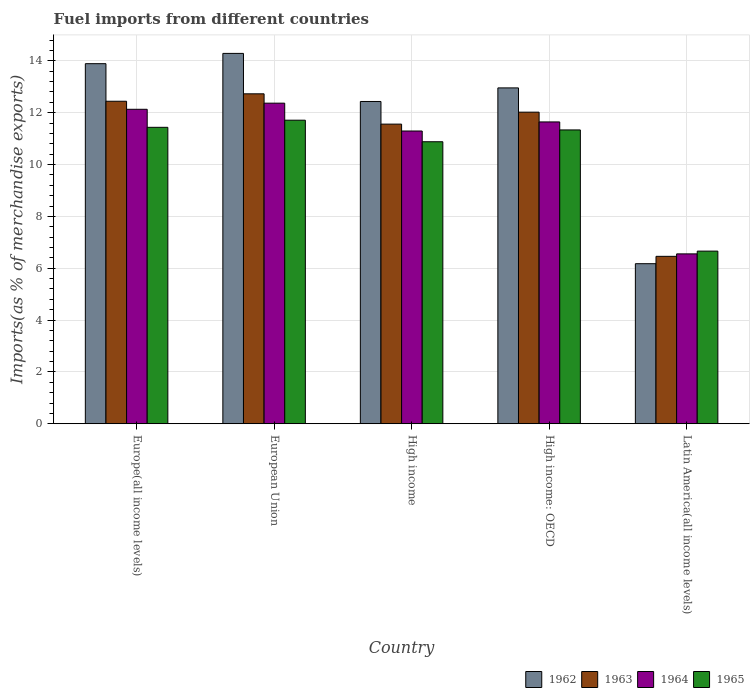Are the number of bars per tick equal to the number of legend labels?
Your answer should be compact. Yes. What is the label of the 1st group of bars from the left?
Offer a terse response. Europe(all income levels). In how many cases, is the number of bars for a given country not equal to the number of legend labels?
Keep it short and to the point. 0. What is the percentage of imports to different countries in 1965 in High income: OECD?
Ensure brevity in your answer.  11.34. Across all countries, what is the maximum percentage of imports to different countries in 1964?
Offer a terse response. 12.37. Across all countries, what is the minimum percentage of imports to different countries in 1963?
Your answer should be very brief. 6.46. In which country was the percentage of imports to different countries in 1964 maximum?
Provide a succinct answer. European Union. In which country was the percentage of imports to different countries in 1963 minimum?
Offer a terse response. Latin America(all income levels). What is the total percentage of imports to different countries in 1962 in the graph?
Your response must be concise. 59.75. What is the difference between the percentage of imports to different countries in 1964 in High income and that in Latin America(all income levels)?
Keep it short and to the point. 4.74. What is the difference between the percentage of imports to different countries in 1963 in High income and the percentage of imports to different countries in 1964 in Latin America(all income levels)?
Your answer should be compact. 5.01. What is the average percentage of imports to different countries in 1963 per country?
Give a very brief answer. 11.04. What is the difference between the percentage of imports to different countries of/in 1964 and percentage of imports to different countries of/in 1963 in Europe(all income levels)?
Offer a terse response. -0.31. What is the ratio of the percentage of imports to different countries in 1965 in Europe(all income levels) to that in High income: OECD?
Make the answer very short. 1.01. What is the difference between the highest and the second highest percentage of imports to different countries in 1963?
Provide a succinct answer. -0.71. What is the difference between the highest and the lowest percentage of imports to different countries in 1965?
Give a very brief answer. 5.05. In how many countries, is the percentage of imports to different countries in 1964 greater than the average percentage of imports to different countries in 1964 taken over all countries?
Your answer should be compact. 4. Is it the case that in every country, the sum of the percentage of imports to different countries in 1963 and percentage of imports to different countries in 1965 is greater than the sum of percentage of imports to different countries in 1964 and percentage of imports to different countries in 1962?
Provide a succinct answer. No. What does the 4th bar from the left in High income represents?
Provide a succinct answer. 1965. Is it the case that in every country, the sum of the percentage of imports to different countries in 1963 and percentage of imports to different countries in 1965 is greater than the percentage of imports to different countries in 1964?
Provide a short and direct response. Yes. Are all the bars in the graph horizontal?
Provide a succinct answer. No. How many countries are there in the graph?
Provide a short and direct response. 5. Are the values on the major ticks of Y-axis written in scientific E-notation?
Make the answer very short. No. Where does the legend appear in the graph?
Provide a short and direct response. Bottom right. How are the legend labels stacked?
Your response must be concise. Horizontal. What is the title of the graph?
Your answer should be very brief. Fuel imports from different countries. Does "1988" appear as one of the legend labels in the graph?
Ensure brevity in your answer.  No. What is the label or title of the X-axis?
Give a very brief answer. Country. What is the label or title of the Y-axis?
Provide a succinct answer. Imports(as % of merchandise exports). What is the Imports(as % of merchandise exports) in 1962 in Europe(all income levels)?
Give a very brief answer. 13.89. What is the Imports(as % of merchandise exports) in 1963 in Europe(all income levels)?
Provide a short and direct response. 12.44. What is the Imports(as % of merchandise exports) in 1964 in Europe(all income levels)?
Provide a succinct answer. 12.13. What is the Imports(as % of merchandise exports) of 1965 in Europe(all income levels)?
Provide a succinct answer. 11.44. What is the Imports(as % of merchandise exports) in 1962 in European Union?
Offer a very short reply. 14.29. What is the Imports(as % of merchandise exports) of 1963 in European Union?
Your answer should be compact. 12.73. What is the Imports(as % of merchandise exports) of 1964 in European Union?
Give a very brief answer. 12.37. What is the Imports(as % of merchandise exports) of 1965 in European Union?
Offer a very short reply. 11.71. What is the Imports(as % of merchandise exports) in 1962 in High income?
Your answer should be very brief. 12.43. What is the Imports(as % of merchandise exports) in 1963 in High income?
Offer a terse response. 11.56. What is the Imports(as % of merchandise exports) of 1964 in High income?
Give a very brief answer. 11.29. What is the Imports(as % of merchandise exports) in 1965 in High income?
Your answer should be compact. 10.88. What is the Imports(as % of merchandise exports) in 1962 in High income: OECD?
Give a very brief answer. 12.96. What is the Imports(as % of merchandise exports) in 1963 in High income: OECD?
Give a very brief answer. 12.02. What is the Imports(as % of merchandise exports) in 1964 in High income: OECD?
Your response must be concise. 11.64. What is the Imports(as % of merchandise exports) of 1965 in High income: OECD?
Ensure brevity in your answer.  11.34. What is the Imports(as % of merchandise exports) of 1962 in Latin America(all income levels)?
Keep it short and to the point. 6.17. What is the Imports(as % of merchandise exports) of 1963 in Latin America(all income levels)?
Your answer should be compact. 6.46. What is the Imports(as % of merchandise exports) in 1964 in Latin America(all income levels)?
Give a very brief answer. 6.55. What is the Imports(as % of merchandise exports) in 1965 in Latin America(all income levels)?
Your answer should be very brief. 6.66. Across all countries, what is the maximum Imports(as % of merchandise exports) in 1962?
Your answer should be compact. 14.29. Across all countries, what is the maximum Imports(as % of merchandise exports) in 1963?
Your answer should be very brief. 12.73. Across all countries, what is the maximum Imports(as % of merchandise exports) in 1964?
Provide a short and direct response. 12.37. Across all countries, what is the maximum Imports(as % of merchandise exports) of 1965?
Give a very brief answer. 11.71. Across all countries, what is the minimum Imports(as % of merchandise exports) of 1962?
Give a very brief answer. 6.17. Across all countries, what is the minimum Imports(as % of merchandise exports) in 1963?
Your answer should be very brief. 6.46. Across all countries, what is the minimum Imports(as % of merchandise exports) in 1964?
Provide a short and direct response. 6.55. Across all countries, what is the minimum Imports(as % of merchandise exports) in 1965?
Your answer should be compact. 6.66. What is the total Imports(as % of merchandise exports) of 1962 in the graph?
Your response must be concise. 59.75. What is the total Imports(as % of merchandise exports) in 1963 in the graph?
Offer a very short reply. 55.21. What is the total Imports(as % of merchandise exports) of 1964 in the graph?
Provide a succinct answer. 53.99. What is the total Imports(as % of merchandise exports) of 1965 in the graph?
Provide a succinct answer. 52.02. What is the difference between the Imports(as % of merchandise exports) in 1962 in Europe(all income levels) and that in European Union?
Give a very brief answer. -0.4. What is the difference between the Imports(as % of merchandise exports) of 1963 in Europe(all income levels) and that in European Union?
Give a very brief answer. -0.29. What is the difference between the Imports(as % of merchandise exports) in 1964 in Europe(all income levels) and that in European Union?
Offer a very short reply. -0.24. What is the difference between the Imports(as % of merchandise exports) of 1965 in Europe(all income levels) and that in European Union?
Your response must be concise. -0.27. What is the difference between the Imports(as % of merchandise exports) in 1962 in Europe(all income levels) and that in High income?
Offer a very short reply. 1.46. What is the difference between the Imports(as % of merchandise exports) in 1963 in Europe(all income levels) and that in High income?
Your response must be concise. 0.88. What is the difference between the Imports(as % of merchandise exports) in 1964 in Europe(all income levels) and that in High income?
Offer a terse response. 0.84. What is the difference between the Imports(as % of merchandise exports) in 1965 in Europe(all income levels) and that in High income?
Offer a terse response. 0.56. What is the difference between the Imports(as % of merchandise exports) in 1962 in Europe(all income levels) and that in High income: OECD?
Make the answer very short. 0.93. What is the difference between the Imports(as % of merchandise exports) in 1963 in Europe(all income levels) and that in High income: OECD?
Offer a terse response. 0.42. What is the difference between the Imports(as % of merchandise exports) in 1964 in Europe(all income levels) and that in High income: OECD?
Your answer should be very brief. 0.49. What is the difference between the Imports(as % of merchandise exports) of 1965 in Europe(all income levels) and that in High income: OECD?
Provide a short and direct response. 0.1. What is the difference between the Imports(as % of merchandise exports) of 1962 in Europe(all income levels) and that in Latin America(all income levels)?
Ensure brevity in your answer.  7.72. What is the difference between the Imports(as % of merchandise exports) in 1963 in Europe(all income levels) and that in Latin America(all income levels)?
Offer a very short reply. 5.98. What is the difference between the Imports(as % of merchandise exports) in 1964 in Europe(all income levels) and that in Latin America(all income levels)?
Ensure brevity in your answer.  5.58. What is the difference between the Imports(as % of merchandise exports) in 1965 in Europe(all income levels) and that in Latin America(all income levels)?
Keep it short and to the point. 4.78. What is the difference between the Imports(as % of merchandise exports) of 1962 in European Union and that in High income?
Offer a terse response. 1.86. What is the difference between the Imports(as % of merchandise exports) in 1963 in European Union and that in High income?
Keep it short and to the point. 1.17. What is the difference between the Imports(as % of merchandise exports) in 1964 in European Union and that in High income?
Make the answer very short. 1.07. What is the difference between the Imports(as % of merchandise exports) in 1965 in European Union and that in High income?
Your answer should be compact. 0.83. What is the difference between the Imports(as % of merchandise exports) in 1962 in European Union and that in High income: OECD?
Provide a short and direct response. 1.33. What is the difference between the Imports(as % of merchandise exports) of 1963 in European Union and that in High income: OECD?
Make the answer very short. 0.71. What is the difference between the Imports(as % of merchandise exports) in 1964 in European Union and that in High income: OECD?
Your answer should be compact. 0.72. What is the difference between the Imports(as % of merchandise exports) of 1965 in European Union and that in High income: OECD?
Offer a terse response. 0.38. What is the difference between the Imports(as % of merchandise exports) in 1962 in European Union and that in Latin America(all income levels)?
Your answer should be compact. 8.11. What is the difference between the Imports(as % of merchandise exports) of 1963 in European Union and that in Latin America(all income levels)?
Your response must be concise. 6.27. What is the difference between the Imports(as % of merchandise exports) of 1964 in European Union and that in Latin America(all income levels)?
Keep it short and to the point. 5.82. What is the difference between the Imports(as % of merchandise exports) in 1965 in European Union and that in Latin America(all income levels)?
Provide a succinct answer. 5.05. What is the difference between the Imports(as % of merchandise exports) in 1962 in High income and that in High income: OECD?
Make the answer very short. -0.52. What is the difference between the Imports(as % of merchandise exports) of 1963 in High income and that in High income: OECD?
Offer a terse response. -0.46. What is the difference between the Imports(as % of merchandise exports) of 1964 in High income and that in High income: OECD?
Keep it short and to the point. -0.35. What is the difference between the Imports(as % of merchandise exports) in 1965 in High income and that in High income: OECD?
Provide a succinct answer. -0.46. What is the difference between the Imports(as % of merchandise exports) of 1962 in High income and that in Latin America(all income levels)?
Your answer should be compact. 6.26. What is the difference between the Imports(as % of merchandise exports) of 1963 in High income and that in Latin America(all income levels)?
Ensure brevity in your answer.  5.1. What is the difference between the Imports(as % of merchandise exports) in 1964 in High income and that in Latin America(all income levels)?
Provide a short and direct response. 4.74. What is the difference between the Imports(as % of merchandise exports) of 1965 in High income and that in Latin America(all income levels)?
Keep it short and to the point. 4.22. What is the difference between the Imports(as % of merchandise exports) of 1962 in High income: OECD and that in Latin America(all income levels)?
Provide a short and direct response. 6.78. What is the difference between the Imports(as % of merchandise exports) of 1963 in High income: OECD and that in Latin America(all income levels)?
Your answer should be very brief. 5.56. What is the difference between the Imports(as % of merchandise exports) in 1964 in High income: OECD and that in Latin America(all income levels)?
Provide a succinct answer. 5.09. What is the difference between the Imports(as % of merchandise exports) of 1965 in High income: OECD and that in Latin America(all income levels)?
Provide a short and direct response. 4.68. What is the difference between the Imports(as % of merchandise exports) in 1962 in Europe(all income levels) and the Imports(as % of merchandise exports) in 1963 in European Union?
Provide a short and direct response. 1.16. What is the difference between the Imports(as % of merchandise exports) of 1962 in Europe(all income levels) and the Imports(as % of merchandise exports) of 1964 in European Union?
Offer a very short reply. 1.52. What is the difference between the Imports(as % of merchandise exports) in 1962 in Europe(all income levels) and the Imports(as % of merchandise exports) in 1965 in European Union?
Give a very brief answer. 2.18. What is the difference between the Imports(as % of merchandise exports) of 1963 in Europe(all income levels) and the Imports(as % of merchandise exports) of 1964 in European Union?
Provide a succinct answer. 0.07. What is the difference between the Imports(as % of merchandise exports) of 1963 in Europe(all income levels) and the Imports(as % of merchandise exports) of 1965 in European Union?
Ensure brevity in your answer.  0.73. What is the difference between the Imports(as % of merchandise exports) of 1964 in Europe(all income levels) and the Imports(as % of merchandise exports) of 1965 in European Union?
Provide a succinct answer. 0.42. What is the difference between the Imports(as % of merchandise exports) in 1962 in Europe(all income levels) and the Imports(as % of merchandise exports) in 1963 in High income?
Offer a very short reply. 2.33. What is the difference between the Imports(as % of merchandise exports) in 1962 in Europe(all income levels) and the Imports(as % of merchandise exports) in 1964 in High income?
Your response must be concise. 2.6. What is the difference between the Imports(as % of merchandise exports) in 1962 in Europe(all income levels) and the Imports(as % of merchandise exports) in 1965 in High income?
Make the answer very short. 3.01. What is the difference between the Imports(as % of merchandise exports) in 1963 in Europe(all income levels) and the Imports(as % of merchandise exports) in 1964 in High income?
Give a very brief answer. 1.15. What is the difference between the Imports(as % of merchandise exports) of 1963 in Europe(all income levels) and the Imports(as % of merchandise exports) of 1965 in High income?
Your answer should be compact. 1.56. What is the difference between the Imports(as % of merchandise exports) of 1964 in Europe(all income levels) and the Imports(as % of merchandise exports) of 1965 in High income?
Your answer should be compact. 1.25. What is the difference between the Imports(as % of merchandise exports) of 1962 in Europe(all income levels) and the Imports(as % of merchandise exports) of 1963 in High income: OECD?
Offer a very short reply. 1.87. What is the difference between the Imports(as % of merchandise exports) in 1962 in Europe(all income levels) and the Imports(as % of merchandise exports) in 1964 in High income: OECD?
Your answer should be compact. 2.25. What is the difference between the Imports(as % of merchandise exports) of 1962 in Europe(all income levels) and the Imports(as % of merchandise exports) of 1965 in High income: OECD?
Ensure brevity in your answer.  2.56. What is the difference between the Imports(as % of merchandise exports) of 1963 in Europe(all income levels) and the Imports(as % of merchandise exports) of 1964 in High income: OECD?
Ensure brevity in your answer.  0.8. What is the difference between the Imports(as % of merchandise exports) in 1963 in Europe(all income levels) and the Imports(as % of merchandise exports) in 1965 in High income: OECD?
Keep it short and to the point. 1.11. What is the difference between the Imports(as % of merchandise exports) of 1964 in Europe(all income levels) and the Imports(as % of merchandise exports) of 1965 in High income: OECD?
Ensure brevity in your answer.  0.8. What is the difference between the Imports(as % of merchandise exports) in 1962 in Europe(all income levels) and the Imports(as % of merchandise exports) in 1963 in Latin America(all income levels)?
Keep it short and to the point. 7.43. What is the difference between the Imports(as % of merchandise exports) of 1962 in Europe(all income levels) and the Imports(as % of merchandise exports) of 1964 in Latin America(all income levels)?
Offer a very short reply. 7.34. What is the difference between the Imports(as % of merchandise exports) in 1962 in Europe(all income levels) and the Imports(as % of merchandise exports) in 1965 in Latin America(all income levels)?
Offer a very short reply. 7.23. What is the difference between the Imports(as % of merchandise exports) of 1963 in Europe(all income levels) and the Imports(as % of merchandise exports) of 1964 in Latin America(all income levels)?
Your response must be concise. 5.89. What is the difference between the Imports(as % of merchandise exports) of 1963 in Europe(all income levels) and the Imports(as % of merchandise exports) of 1965 in Latin America(all income levels)?
Make the answer very short. 5.78. What is the difference between the Imports(as % of merchandise exports) in 1964 in Europe(all income levels) and the Imports(as % of merchandise exports) in 1965 in Latin America(all income levels)?
Provide a short and direct response. 5.47. What is the difference between the Imports(as % of merchandise exports) in 1962 in European Union and the Imports(as % of merchandise exports) in 1963 in High income?
Keep it short and to the point. 2.73. What is the difference between the Imports(as % of merchandise exports) in 1962 in European Union and the Imports(as % of merchandise exports) in 1964 in High income?
Provide a succinct answer. 2.99. What is the difference between the Imports(as % of merchandise exports) in 1962 in European Union and the Imports(as % of merchandise exports) in 1965 in High income?
Your response must be concise. 3.41. What is the difference between the Imports(as % of merchandise exports) of 1963 in European Union and the Imports(as % of merchandise exports) of 1964 in High income?
Your response must be concise. 1.43. What is the difference between the Imports(as % of merchandise exports) in 1963 in European Union and the Imports(as % of merchandise exports) in 1965 in High income?
Give a very brief answer. 1.85. What is the difference between the Imports(as % of merchandise exports) in 1964 in European Union and the Imports(as % of merchandise exports) in 1965 in High income?
Provide a short and direct response. 1.49. What is the difference between the Imports(as % of merchandise exports) in 1962 in European Union and the Imports(as % of merchandise exports) in 1963 in High income: OECD?
Your answer should be compact. 2.27. What is the difference between the Imports(as % of merchandise exports) of 1962 in European Union and the Imports(as % of merchandise exports) of 1964 in High income: OECD?
Your answer should be very brief. 2.64. What is the difference between the Imports(as % of merchandise exports) in 1962 in European Union and the Imports(as % of merchandise exports) in 1965 in High income: OECD?
Keep it short and to the point. 2.95. What is the difference between the Imports(as % of merchandise exports) of 1963 in European Union and the Imports(as % of merchandise exports) of 1964 in High income: OECD?
Offer a terse response. 1.08. What is the difference between the Imports(as % of merchandise exports) of 1963 in European Union and the Imports(as % of merchandise exports) of 1965 in High income: OECD?
Offer a terse response. 1.39. What is the difference between the Imports(as % of merchandise exports) of 1964 in European Union and the Imports(as % of merchandise exports) of 1965 in High income: OECD?
Your answer should be very brief. 1.03. What is the difference between the Imports(as % of merchandise exports) of 1962 in European Union and the Imports(as % of merchandise exports) of 1963 in Latin America(all income levels)?
Your response must be concise. 7.83. What is the difference between the Imports(as % of merchandise exports) of 1962 in European Union and the Imports(as % of merchandise exports) of 1964 in Latin America(all income levels)?
Make the answer very short. 7.74. What is the difference between the Imports(as % of merchandise exports) in 1962 in European Union and the Imports(as % of merchandise exports) in 1965 in Latin America(all income levels)?
Make the answer very short. 7.63. What is the difference between the Imports(as % of merchandise exports) in 1963 in European Union and the Imports(as % of merchandise exports) in 1964 in Latin America(all income levels)?
Offer a very short reply. 6.18. What is the difference between the Imports(as % of merchandise exports) of 1963 in European Union and the Imports(as % of merchandise exports) of 1965 in Latin America(all income levels)?
Give a very brief answer. 6.07. What is the difference between the Imports(as % of merchandise exports) of 1964 in European Union and the Imports(as % of merchandise exports) of 1965 in Latin America(all income levels)?
Provide a succinct answer. 5.71. What is the difference between the Imports(as % of merchandise exports) of 1962 in High income and the Imports(as % of merchandise exports) of 1963 in High income: OECD?
Offer a very short reply. 0.41. What is the difference between the Imports(as % of merchandise exports) of 1962 in High income and the Imports(as % of merchandise exports) of 1964 in High income: OECD?
Offer a very short reply. 0.79. What is the difference between the Imports(as % of merchandise exports) of 1962 in High income and the Imports(as % of merchandise exports) of 1965 in High income: OECD?
Your answer should be compact. 1.1. What is the difference between the Imports(as % of merchandise exports) of 1963 in High income and the Imports(as % of merchandise exports) of 1964 in High income: OECD?
Provide a short and direct response. -0.09. What is the difference between the Imports(as % of merchandise exports) of 1963 in High income and the Imports(as % of merchandise exports) of 1965 in High income: OECD?
Provide a succinct answer. 0.22. What is the difference between the Imports(as % of merchandise exports) in 1964 in High income and the Imports(as % of merchandise exports) in 1965 in High income: OECD?
Offer a very short reply. -0.04. What is the difference between the Imports(as % of merchandise exports) of 1962 in High income and the Imports(as % of merchandise exports) of 1963 in Latin America(all income levels)?
Your response must be concise. 5.97. What is the difference between the Imports(as % of merchandise exports) of 1962 in High income and the Imports(as % of merchandise exports) of 1964 in Latin America(all income levels)?
Provide a short and direct response. 5.88. What is the difference between the Imports(as % of merchandise exports) of 1962 in High income and the Imports(as % of merchandise exports) of 1965 in Latin America(all income levels)?
Offer a very short reply. 5.77. What is the difference between the Imports(as % of merchandise exports) in 1963 in High income and the Imports(as % of merchandise exports) in 1964 in Latin America(all income levels)?
Your answer should be compact. 5.01. What is the difference between the Imports(as % of merchandise exports) of 1963 in High income and the Imports(as % of merchandise exports) of 1965 in Latin America(all income levels)?
Offer a terse response. 4.9. What is the difference between the Imports(as % of merchandise exports) of 1964 in High income and the Imports(as % of merchandise exports) of 1965 in Latin America(all income levels)?
Provide a short and direct response. 4.63. What is the difference between the Imports(as % of merchandise exports) of 1962 in High income: OECD and the Imports(as % of merchandise exports) of 1963 in Latin America(all income levels)?
Ensure brevity in your answer.  6.5. What is the difference between the Imports(as % of merchandise exports) in 1962 in High income: OECD and the Imports(as % of merchandise exports) in 1964 in Latin America(all income levels)?
Provide a short and direct response. 6.4. What is the difference between the Imports(as % of merchandise exports) of 1962 in High income: OECD and the Imports(as % of merchandise exports) of 1965 in Latin America(all income levels)?
Keep it short and to the point. 6.3. What is the difference between the Imports(as % of merchandise exports) of 1963 in High income: OECD and the Imports(as % of merchandise exports) of 1964 in Latin America(all income levels)?
Offer a very short reply. 5.47. What is the difference between the Imports(as % of merchandise exports) of 1963 in High income: OECD and the Imports(as % of merchandise exports) of 1965 in Latin America(all income levels)?
Your answer should be compact. 5.36. What is the difference between the Imports(as % of merchandise exports) in 1964 in High income: OECD and the Imports(as % of merchandise exports) in 1965 in Latin America(all income levels)?
Provide a short and direct response. 4.98. What is the average Imports(as % of merchandise exports) in 1962 per country?
Your answer should be compact. 11.95. What is the average Imports(as % of merchandise exports) of 1963 per country?
Provide a short and direct response. 11.04. What is the average Imports(as % of merchandise exports) in 1964 per country?
Make the answer very short. 10.8. What is the average Imports(as % of merchandise exports) of 1965 per country?
Give a very brief answer. 10.4. What is the difference between the Imports(as % of merchandise exports) in 1962 and Imports(as % of merchandise exports) in 1963 in Europe(all income levels)?
Ensure brevity in your answer.  1.45. What is the difference between the Imports(as % of merchandise exports) in 1962 and Imports(as % of merchandise exports) in 1964 in Europe(all income levels)?
Make the answer very short. 1.76. What is the difference between the Imports(as % of merchandise exports) in 1962 and Imports(as % of merchandise exports) in 1965 in Europe(all income levels)?
Your answer should be compact. 2.46. What is the difference between the Imports(as % of merchandise exports) of 1963 and Imports(as % of merchandise exports) of 1964 in Europe(all income levels)?
Your answer should be compact. 0.31. What is the difference between the Imports(as % of merchandise exports) of 1963 and Imports(as % of merchandise exports) of 1965 in Europe(all income levels)?
Offer a very short reply. 1.01. What is the difference between the Imports(as % of merchandise exports) in 1964 and Imports(as % of merchandise exports) in 1965 in Europe(all income levels)?
Your response must be concise. 0.7. What is the difference between the Imports(as % of merchandise exports) of 1962 and Imports(as % of merchandise exports) of 1963 in European Union?
Your answer should be very brief. 1.56. What is the difference between the Imports(as % of merchandise exports) of 1962 and Imports(as % of merchandise exports) of 1964 in European Union?
Give a very brief answer. 1.92. What is the difference between the Imports(as % of merchandise exports) in 1962 and Imports(as % of merchandise exports) in 1965 in European Union?
Ensure brevity in your answer.  2.58. What is the difference between the Imports(as % of merchandise exports) in 1963 and Imports(as % of merchandise exports) in 1964 in European Union?
Ensure brevity in your answer.  0.36. What is the difference between the Imports(as % of merchandise exports) of 1963 and Imports(as % of merchandise exports) of 1965 in European Union?
Give a very brief answer. 1.02. What is the difference between the Imports(as % of merchandise exports) in 1964 and Imports(as % of merchandise exports) in 1965 in European Union?
Your answer should be very brief. 0.66. What is the difference between the Imports(as % of merchandise exports) of 1962 and Imports(as % of merchandise exports) of 1963 in High income?
Give a very brief answer. 0.87. What is the difference between the Imports(as % of merchandise exports) of 1962 and Imports(as % of merchandise exports) of 1964 in High income?
Offer a terse response. 1.14. What is the difference between the Imports(as % of merchandise exports) of 1962 and Imports(as % of merchandise exports) of 1965 in High income?
Provide a short and direct response. 1.55. What is the difference between the Imports(as % of merchandise exports) in 1963 and Imports(as % of merchandise exports) in 1964 in High income?
Give a very brief answer. 0.27. What is the difference between the Imports(as % of merchandise exports) in 1963 and Imports(as % of merchandise exports) in 1965 in High income?
Keep it short and to the point. 0.68. What is the difference between the Imports(as % of merchandise exports) of 1964 and Imports(as % of merchandise exports) of 1965 in High income?
Provide a succinct answer. 0.41. What is the difference between the Imports(as % of merchandise exports) in 1962 and Imports(as % of merchandise exports) in 1963 in High income: OECD?
Provide a short and direct response. 0.94. What is the difference between the Imports(as % of merchandise exports) of 1962 and Imports(as % of merchandise exports) of 1964 in High income: OECD?
Keep it short and to the point. 1.31. What is the difference between the Imports(as % of merchandise exports) of 1962 and Imports(as % of merchandise exports) of 1965 in High income: OECD?
Provide a succinct answer. 1.62. What is the difference between the Imports(as % of merchandise exports) of 1963 and Imports(as % of merchandise exports) of 1964 in High income: OECD?
Keep it short and to the point. 0.38. What is the difference between the Imports(as % of merchandise exports) of 1963 and Imports(as % of merchandise exports) of 1965 in High income: OECD?
Provide a short and direct response. 0.69. What is the difference between the Imports(as % of merchandise exports) in 1964 and Imports(as % of merchandise exports) in 1965 in High income: OECD?
Keep it short and to the point. 0.31. What is the difference between the Imports(as % of merchandise exports) of 1962 and Imports(as % of merchandise exports) of 1963 in Latin America(all income levels)?
Your response must be concise. -0.28. What is the difference between the Imports(as % of merchandise exports) of 1962 and Imports(as % of merchandise exports) of 1964 in Latin America(all income levels)?
Ensure brevity in your answer.  -0.38. What is the difference between the Imports(as % of merchandise exports) in 1962 and Imports(as % of merchandise exports) in 1965 in Latin America(all income levels)?
Keep it short and to the point. -0.48. What is the difference between the Imports(as % of merchandise exports) in 1963 and Imports(as % of merchandise exports) in 1964 in Latin America(all income levels)?
Provide a short and direct response. -0.09. What is the difference between the Imports(as % of merchandise exports) in 1963 and Imports(as % of merchandise exports) in 1965 in Latin America(all income levels)?
Offer a terse response. -0.2. What is the difference between the Imports(as % of merchandise exports) of 1964 and Imports(as % of merchandise exports) of 1965 in Latin America(all income levels)?
Provide a succinct answer. -0.11. What is the ratio of the Imports(as % of merchandise exports) of 1962 in Europe(all income levels) to that in European Union?
Your answer should be compact. 0.97. What is the ratio of the Imports(as % of merchandise exports) of 1963 in Europe(all income levels) to that in European Union?
Provide a succinct answer. 0.98. What is the ratio of the Imports(as % of merchandise exports) of 1964 in Europe(all income levels) to that in European Union?
Your answer should be very brief. 0.98. What is the ratio of the Imports(as % of merchandise exports) of 1965 in Europe(all income levels) to that in European Union?
Provide a short and direct response. 0.98. What is the ratio of the Imports(as % of merchandise exports) in 1962 in Europe(all income levels) to that in High income?
Your answer should be very brief. 1.12. What is the ratio of the Imports(as % of merchandise exports) of 1963 in Europe(all income levels) to that in High income?
Your answer should be compact. 1.08. What is the ratio of the Imports(as % of merchandise exports) of 1964 in Europe(all income levels) to that in High income?
Ensure brevity in your answer.  1.07. What is the ratio of the Imports(as % of merchandise exports) of 1965 in Europe(all income levels) to that in High income?
Offer a very short reply. 1.05. What is the ratio of the Imports(as % of merchandise exports) in 1962 in Europe(all income levels) to that in High income: OECD?
Offer a terse response. 1.07. What is the ratio of the Imports(as % of merchandise exports) in 1963 in Europe(all income levels) to that in High income: OECD?
Keep it short and to the point. 1.04. What is the ratio of the Imports(as % of merchandise exports) of 1964 in Europe(all income levels) to that in High income: OECD?
Your response must be concise. 1.04. What is the ratio of the Imports(as % of merchandise exports) in 1965 in Europe(all income levels) to that in High income: OECD?
Your response must be concise. 1.01. What is the ratio of the Imports(as % of merchandise exports) of 1962 in Europe(all income levels) to that in Latin America(all income levels)?
Your answer should be compact. 2.25. What is the ratio of the Imports(as % of merchandise exports) in 1963 in Europe(all income levels) to that in Latin America(all income levels)?
Offer a very short reply. 1.93. What is the ratio of the Imports(as % of merchandise exports) in 1964 in Europe(all income levels) to that in Latin America(all income levels)?
Make the answer very short. 1.85. What is the ratio of the Imports(as % of merchandise exports) in 1965 in Europe(all income levels) to that in Latin America(all income levels)?
Offer a terse response. 1.72. What is the ratio of the Imports(as % of merchandise exports) in 1962 in European Union to that in High income?
Your response must be concise. 1.15. What is the ratio of the Imports(as % of merchandise exports) of 1963 in European Union to that in High income?
Your answer should be compact. 1.1. What is the ratio of the Imports(as % of merchandise exports) in 1964 in European Union to that in High income?
Give a very brief answer. 1.1. What is the ratio of the Imports(as % of merchandise exports) in 1965 in European Union to that in High income?
Offer a very short reply. 1.08. What is the ratio of the Imports(as % of merchandise exports) of 1962 in European Union to that in High income: OECD?
Your answer should be very brief. 1.1. What is the ratio of the Imports(as % of merchandise exports) in 1963 in European Union to that in High income: OECD?
Provide a short and direct response. 1.06. What is the ratio of the Imports(as % of merchandise exports) in 1964 in European Union to that in High income: OECD?
Your answer should be very brief. 1.06. What is the ratio of the Imports(as % of merchandise exports) of 1965 in European Union to that in High income: OECD?
Make the answer very short. 1.03. What is the ratio of the Imports(as % of merchandise exports) of 1962 in European Union to that in Latin America(all income levels)?
Keep it short and to the point. 2.31. What is the ratio of the Imports(as % of merchandise exports) of 1963 in European Union to that in Latin America(all income levels)?
Offer a terse response. 1.97. What is the ratio of the Imports(as % of merchandise exports) in 1964 in European Union to that in Latin America(all income levels)?
Your answer should be compact. 1.89. What is the ratio of the Imports(as % of merchandise exports) of 1965 in European Union to that in Latin America(all income levels)?
Your answer should be very brief. 1.76. What is the ratio of the Imports(as % of merchandise exports) of 1962 in High income to that in High income: OECD?
Make the answer very short. 0.96. What is the ratio of the Imports(as % of merchandise exports) in 1963 in High income to that in High income: OECD?
Provide a short and direct response. 0.96. What is the ratio of the Imports(as % of merchandise exports) in 1964 in High income to that in High income: OECD?
Offer a very short reply. 0.97. What is the ratio of the Imports(as % of merchandise exports) in 1965 in High income to that in High income: OECD?
Provide a succinct answer. 0.96. What is the ratio of the Imports(as % of merchandise exports) of 1962 in High income to that in Latin America(all income levels)?
Provide a succinct answer. 2.01. What is the ratio of the Imports(as % of merchandise exports) of 1963 in High income to that in Latin America(all income levels)?
Provide a short and direct response. 1.79. What is the ratio of the Imports(as % of merchandise exports) of 1964 in High income to that in Latin America(all income levels)?
Provide a short and direct response. 1.72. What is the ratio of the Imports(as % of merchandise exports) of 1965 in High income to that in Latin America(all income levels)?
Provide a succinct answer. 1.63. What is the ratio of the Imports(as % of merchandise exports) in 1962 in High income: OECD to that in Latin America(all income levels)?
Offer a terse response. 2.1. What is the ratio of the Imports(as % of merchandise exports) of 1963 in High income: OECD to that in Latin America(all income levels)?
Provide a short and direct response. 1.86. What is the ratio of the Imports(as % of merchandise exports) of 1964 in High income: OECD to that in Latin America(all income levels)?
Your answer should be compact. 1.78. What is the ratio of the Imports(as % of merchandise exports) in 1965 in High income: OECD to that in Latin America(all income levels)?
Your answer should be compact. 1.7. What is the difference between the highest and the second highest Imports(as % of merchandise exports) in 1962?
Offer a terse response. 0.4. What is the difference between the highest and the second highest Imports(as % of merchandise exports) of 1963?
Keep it short and to the point. 0.29. What is the difference between the highest and the second highest Imports(as % of merchandise exports) of 1964?
Your response must be concise. 0.24. What is the difference between the highest and the second highest Imports(as % of merchandise exports) of 1965?
Provide a succinct answer. 0.27. What is the difference between the highest and the lowest Imports(as % of merchandise exports) of 1962?
Offer a terse response. 8.11. What is the difference between the highest and the lowest Imports(as % of merchandise exports) in 1963?
Provide a short and direct response. 6.27. What is the difference between the highest and the lowest Imports(as % of merchandise exports) of 1964?
Your answer should be very brief. 5.82. What is the difference between the highest and the lowest Imports(as % of merchandise exports) of 1965?
Your response must be concise. 5.05. 